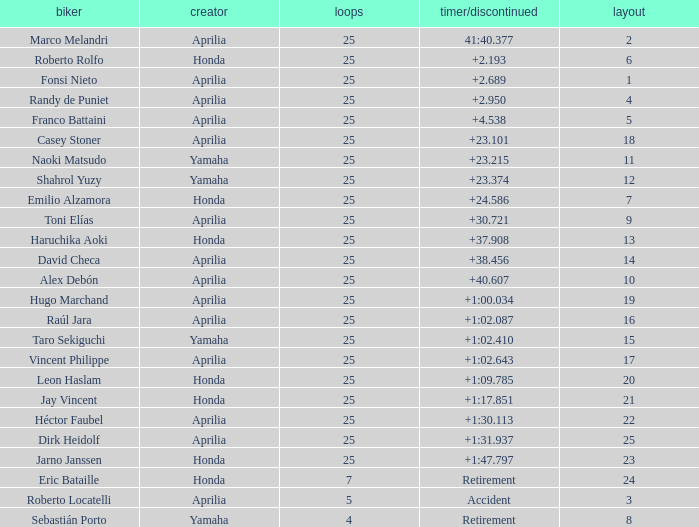Which Manufacturer has a Time/Retired of accident? Aprilia. 